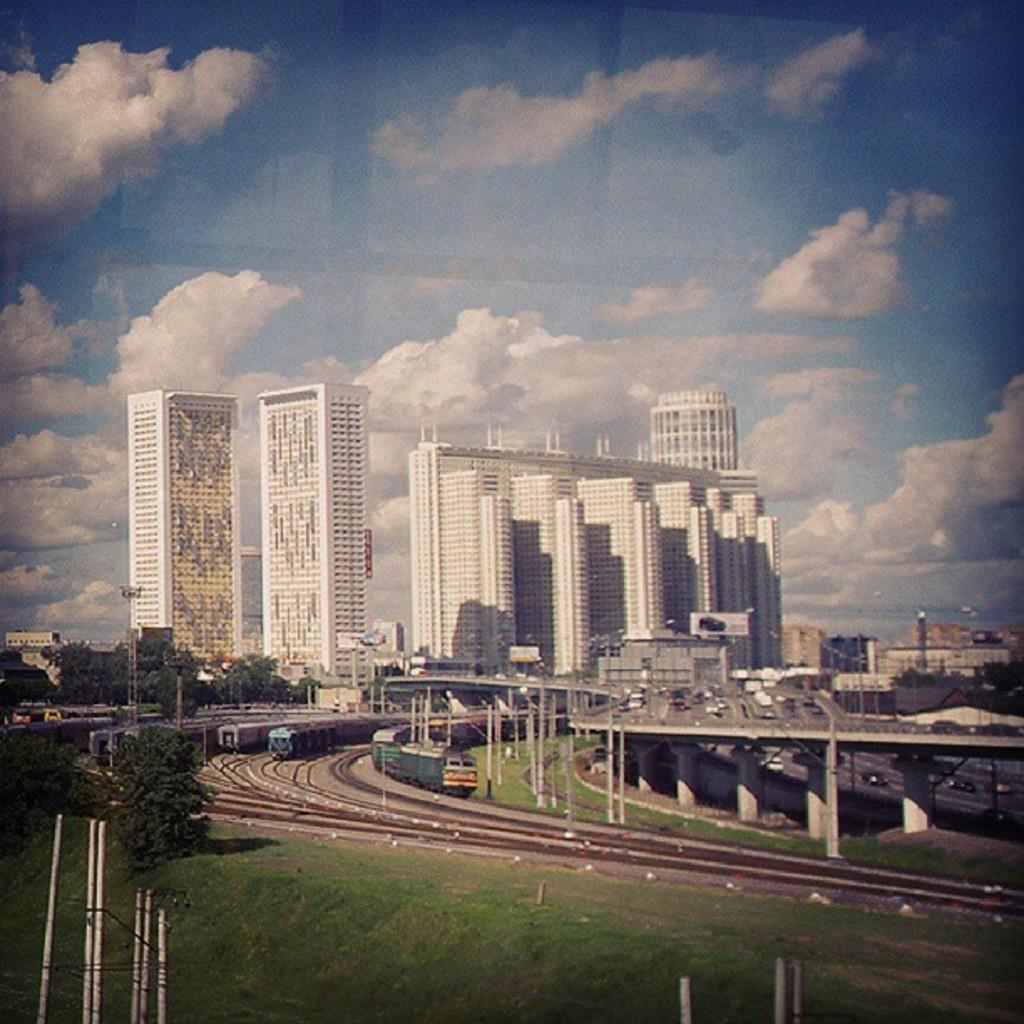What type of vegetation can be seen in the image? There is grass and trees in the image. What type of transportation infrastructure is present in the image? Railway tracks and trains are visible in the image. What type of structure is present in the image? There is a bridge in the image. What type of vehicles can be seen in the image? Vehicles are present in the image. What type of urban environment is depicted in the image? There are many buildings in the image. What is the smell of the banana in the image? There is no banana present in the image, so it is not possible to determine its smell. 